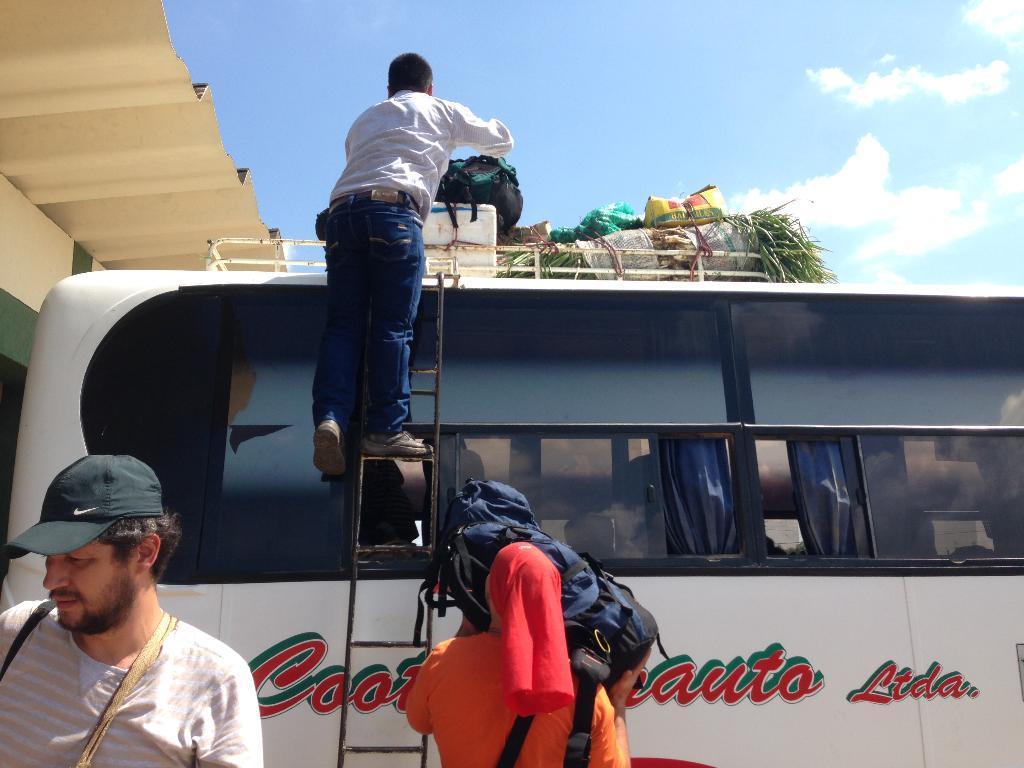Describe this image in one or two sentences. In this picture, there is a bus and a person climbing the bus with a ladder. He is placing a bag on the top of the bus. At the bottom, there is a man and woman. Woman is carrying a bag. On the top, there is a sky with clouds. 